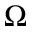<formula> <loc_0><loc_0><loc_500><loc_500>\Omega</formula> 